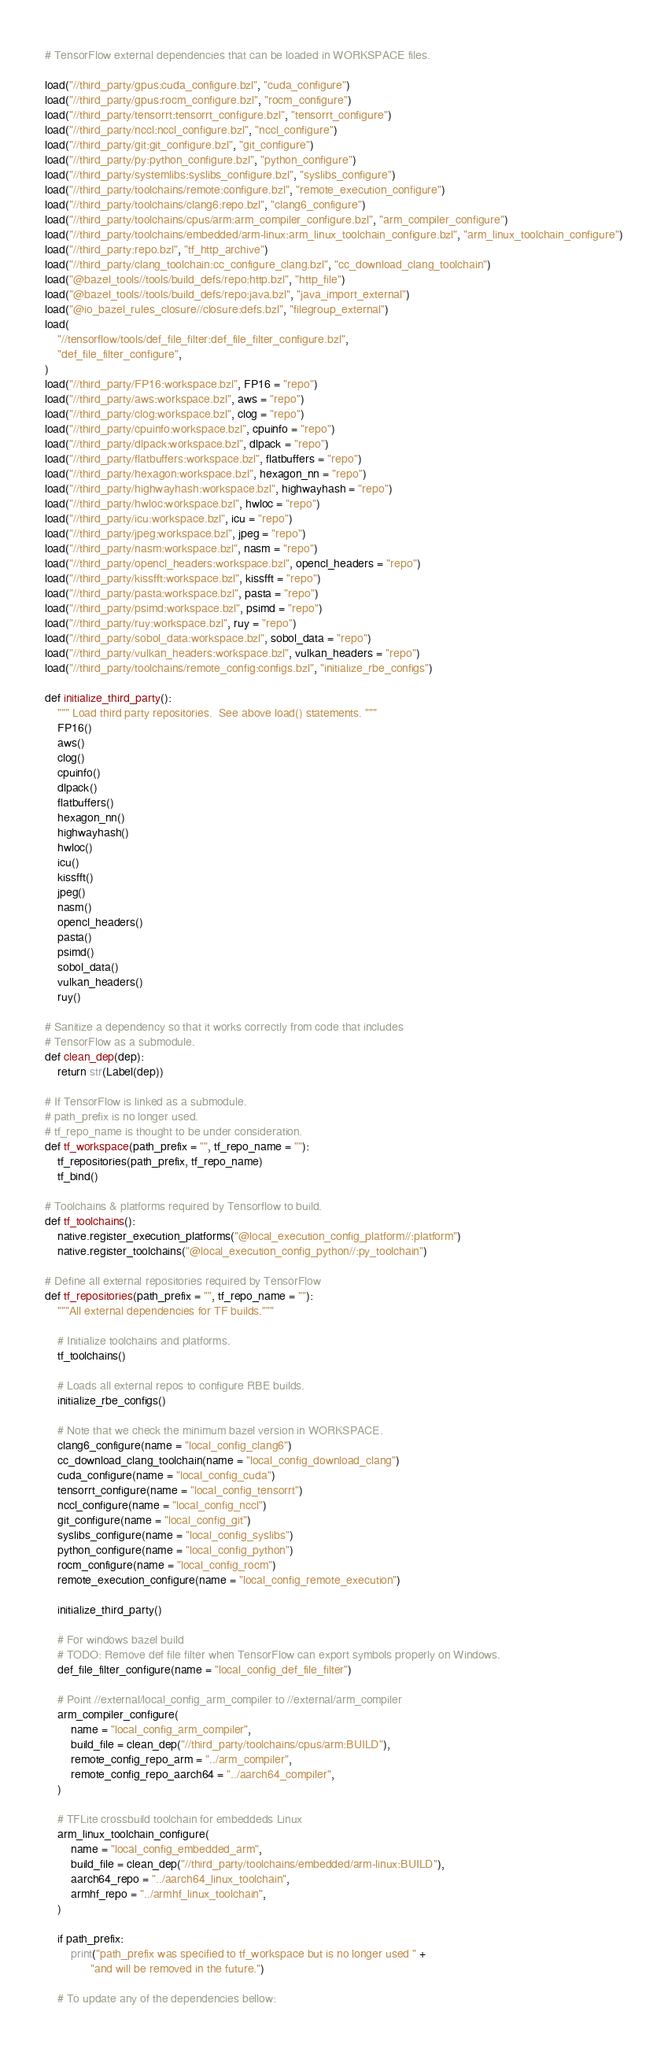Convert code to text. <code><loc_0><loc_0><loc_500><loc_500><_Python_># TensorFlow external dependencies that can be loaded in WORKSPACE files.

load("//third_party/gpus:cuda_configure.bzl", "cuda_configure")
load("//third_party/gpus:rocm_configure.bzl", "rocm_configure")
load("//third_party/tensorrt:tensorrt_configure.bzl", "tensorrt_configure")
load("//third_party/nccl:nccl_configure.bzl", "nccl_configure")
load("//third_party/git:git_configure.bzl", "git_configure")
load("//third_party/py:python_configure.bzl", "python_configure")
load("//third_party/systemlibs:syslibs_configure.bzl", "syslibs_configure")
load("//third_party/toolchains/remote:configure.bzl", "remote_execution_configure")
load("//third_party/toolchains/clang6:repo.bzl", "clang6_configure")
load("//third_party/toolchains/cpus/arm:arm_compiler_configure.bzl", "arm_compiler_configure")
load("//third_party/toolchains/embedded/arm-linux:arm_linux_toolchain_configure.bzl", "arm_linux_toolchain_configure")
load("//third_party:repo.bzl", "tf_http_archive")
load("//third_party/clang_toolchain:cc_configure_clang.bzl", "cc_download_clang_toolchain")
load("@bazel_tools//tools/build_defs/repo:http.bzl", "http_file")
load("@bazel_tools//tools/build_defs/repo:java.bzl", "java_import_external")
load("@io_bazel_rules_closure//closure:defs.bzl", "filegroup_external")
load(
    "//tensorflow/tools/def_file_filter:def_file_filter_configure.bzl",
    "def_file_filter_configure",
)
load("//third_party/FP16:workspace.bzl", FP16 = "repo")
load("//third_party/aws:workspace.bzl", aws = "repo")
load("//third_party/clog:workspace.bzl", clog = "repo")
load("//third_party/cpuinfo:workspace.bzl", cpuinfo = "repo")
load("//third_party/dlpack:workspace.bzl", dlpack = "repo")
load("//third_party/flatbuffers:workspace.bzl", flatbuffers = "repo")
load("//third_party/hexagon:workspace.bzl", hexagon_nn = "repo")
load("//third_party/highwayhash:workspace.bzl", highwayhash = "repo")
load("//third_party/hwloc:workspace.bzl", hwloc = "repo")
load("//third_party/icu:workspace.bzl", icu = "repo")
load("//third_party/jpeg:workspace.bzl", jpeg = "repo")
load("//third_party/nasm:workspace.bzl", nasm = "repo")
load("//third_party/opencl_headers:workspace.bzl", opencl_headers = "repo")
load("//third_party/kissfft:workspace.bzl", kissfft = "repo")
load("//third_party/pasta:workspace.bzl", pasta = "repo")
load("//third_party/psimd:workspace.bzl", psimd = "repo")
load("//third_party/ruy:workspace.bzl", ruy = "repo")
load("//third_party/sobol_data:workspace.bzl", sobol_data = "repo")
load("//third_party/vulkan_headers:workspace.bzl", vulkan_headers = "repo")
load("//third_party/toolchains/remote_config:configs.bzl", "initialize_rbe_configs")

def initialize_third_party():
    """ Load third party repositories.  See above load() statements. """
    FP16()
    aws()
    clog()
    cpuinfo()
    dlpack()
    flatbuffers()
    hexagon_nn()
    highwayhash()
    hwloc()
    icu()
    kissfft()
    jpeg()
    nasm()
    opencl_headers()
    pasta()
    psimd()
    sobol_data()
    vulkan_headers()
    ruy()

# Sanitize a dependency so that it works correctly from code that includes
# TensorFlow as a submodule.
def clean_dep(dep):
    return str(Label(dep))

# If TensorFlow is linked as a submodule.
# path_prefix is no longer used.
# tf_repo_name is thought to be under consideration.
def tf_workspace(path_prefix = "", tf_repo_name = ""):
    tf_repositories(path_prefix, tf_repo_name)
    tf_bind()

# Toolchains & platforms required by Tensorflow to build.
def tf_toolchains():
    native.register_execution_platforms("@local_execution_config_platform//:platform")
    native.register_toolchains("@local_execution_config_python//:py_toolchain")

# Define all external repositories required by TensorFlow
def tf_repositories(path_prefix = "", tf_repo_name = ""):
    """All external dependencies for TF builds."""

    # Initialize toolchains and platforms.
    tf_toolchains()

    # Loads all external repos to configure RBE builds.
    initialize_rbe_configs()

    # Note that we check the minimum bazel version in WORKSPACE.
    clang6_configure(name = "local_config_clang6")
    cc_download_clang_toolchain(name = "local_config_download_clang")
    cuda_configure(name = "local_config_cuda")
    tensorrt_configure(name = "local_config_tensorrt")
    nccl_configure(name = "local_config_nccl")
    git_configure(name = "local_config_git")
    syslibs_configure(name = "local_config_syslibs")
    python_configure(name = "local_config_python")
    rocm_configure(name = "local_config_rocm")
    remote_execution_configure(name = "local_config_remote_execution")

    initialize_third_party()

    # For windows bazel build
    # TODO: Remove def file filter when TensorFlow can export symbols properly on Windows.
    def_file_filter_configure(name = "local_config_def_file_filter")

    # Point //external/local_config_arm_compiler to //external/arm_compiler
    arm_compiler_configure(
        name = "local_config_arm_compiler",
        build_file = clean_dep("//third_party/toolchains/cpus/arm:BUILD"),
        remote_config_repo_arm = "../arm_compiler",
        remote_config_repo_aarch64 = "../aarch64_compiler",
    )

    # TFLite crossbuild toolchain for embeddeds Linux
    arm_linux_toolchain_configure(
        name = "local_config_embedded_arm",
        build_file = clean_dep("//third_party/toolchains/embedded/arm-linux:BUILD"),
        aarch64_repo = "../aarch64_linux_toolchain",
        armhf_repo = "../armhf_linux_toolchain",
    )

    if path_prefix:
        print("path_prefix was specified to tf_workspace but is no longer used " +
              "and will be removed in the future.")

    # To update any of the dependencies bellow:</code> 